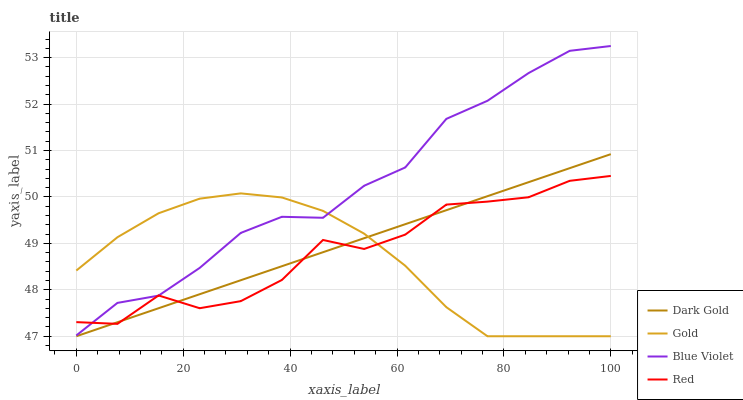Does Blue Violet have the minimum area under the curve?
Answer yes or no. No. Does Gold have the maximum area under the curve?
Answer yes or no. No. Is Blue Violet the smoothest?
Answer yes or no. No. Is Blue Violet the roughest?
Answer yes or no. No. Does Blue Violet have the lowest value?
Answer yes or no. No. Does Gold have the highest value?
Answer yes or no. No. Is Dark Gold less than Blue Violet?
Answer yes or no. Yes. Is Blue Violet greater than Dark Gold?
Answer yes or no. Yes. Does Dark Gold intersect Blue Violet?
Answer yes or no. No. 